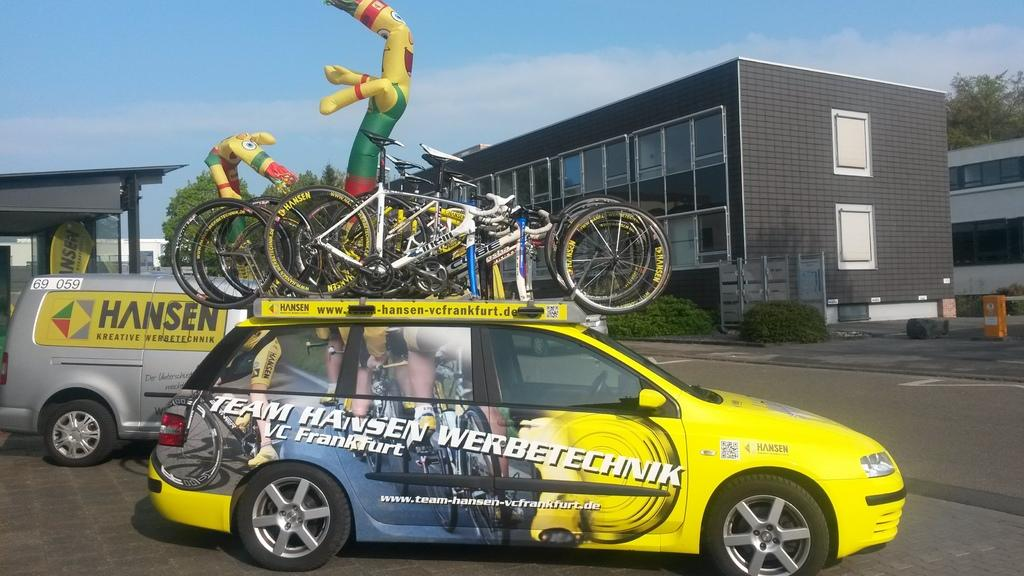<image>
Give a short and clear explanation of the subsequent image. a car that has the name Hansen on it 